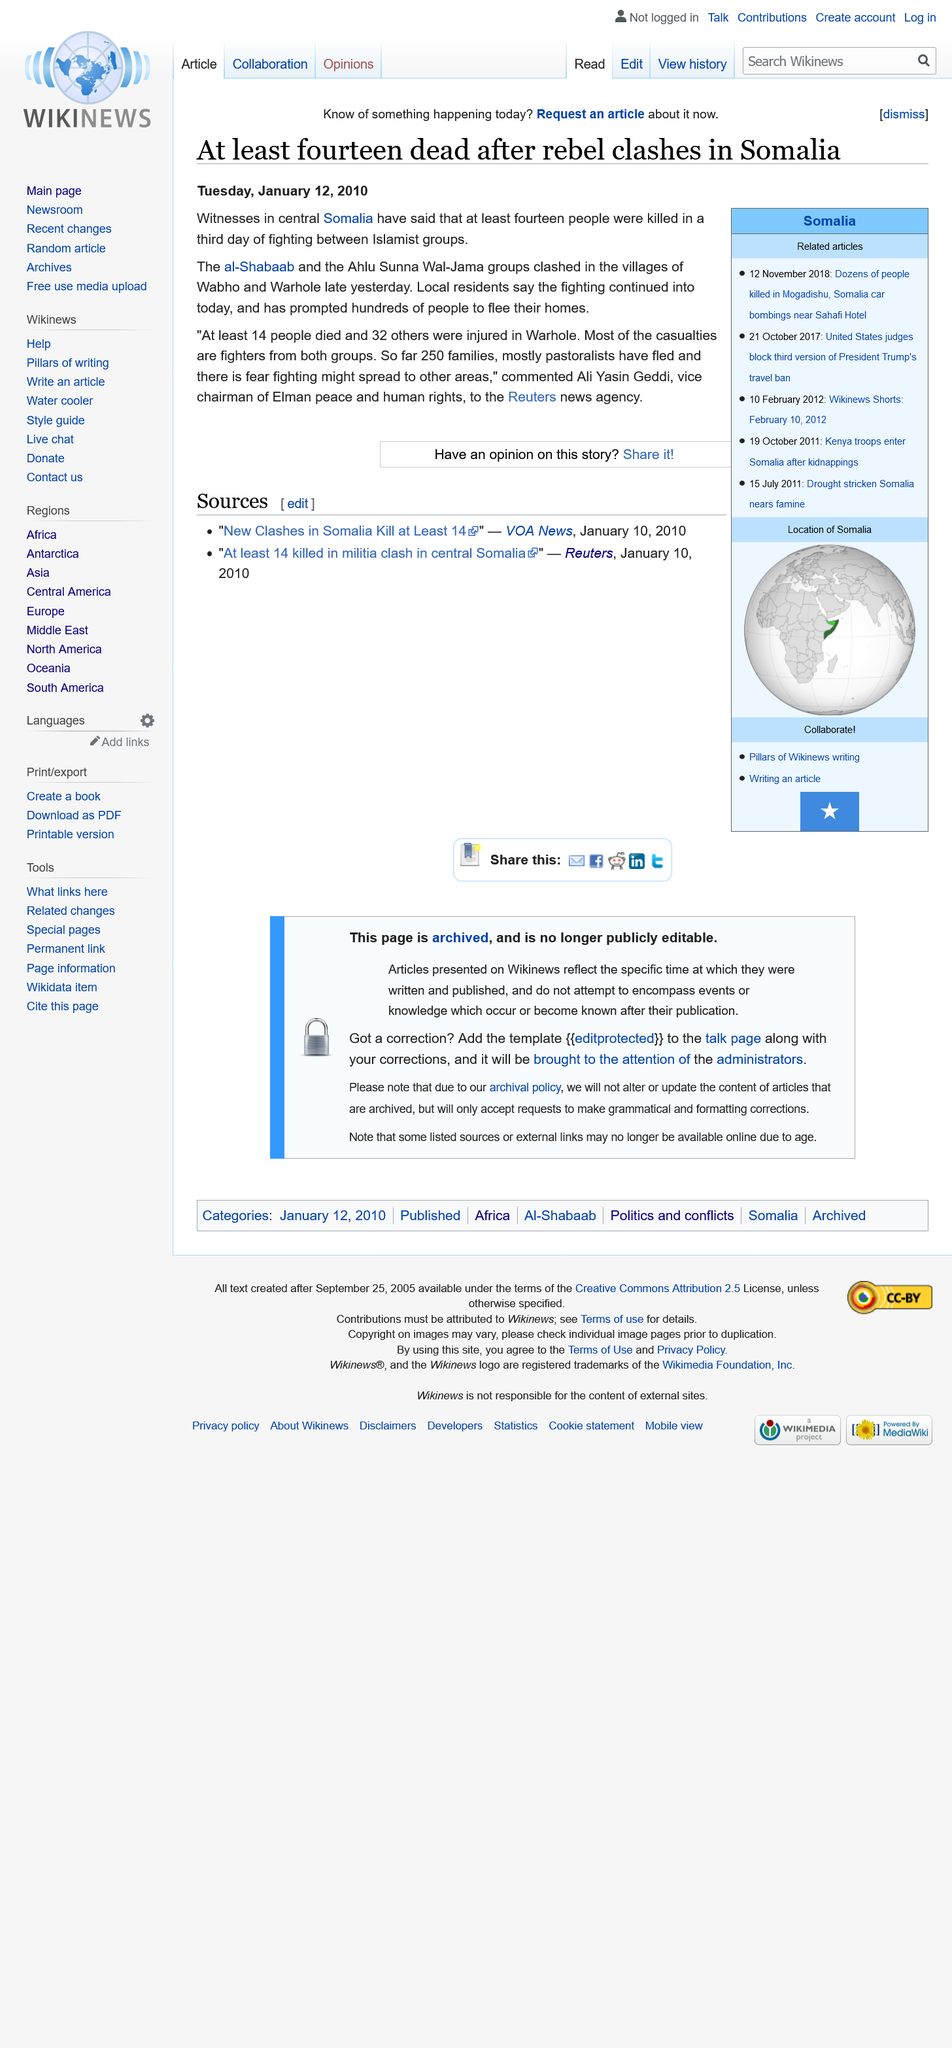Give some essential details in this illustration. In the villages of Wahoo and Warhole, clashes occurred between the Islamist group al-Shabaab and the Ahlu Summa Wal-Jama. On the third day of fighting in central Somalia, at least fourteen people were killed and witnesses reported the violence. To date, 250 families have fled the violence due to the ongoing conflict in the region. 